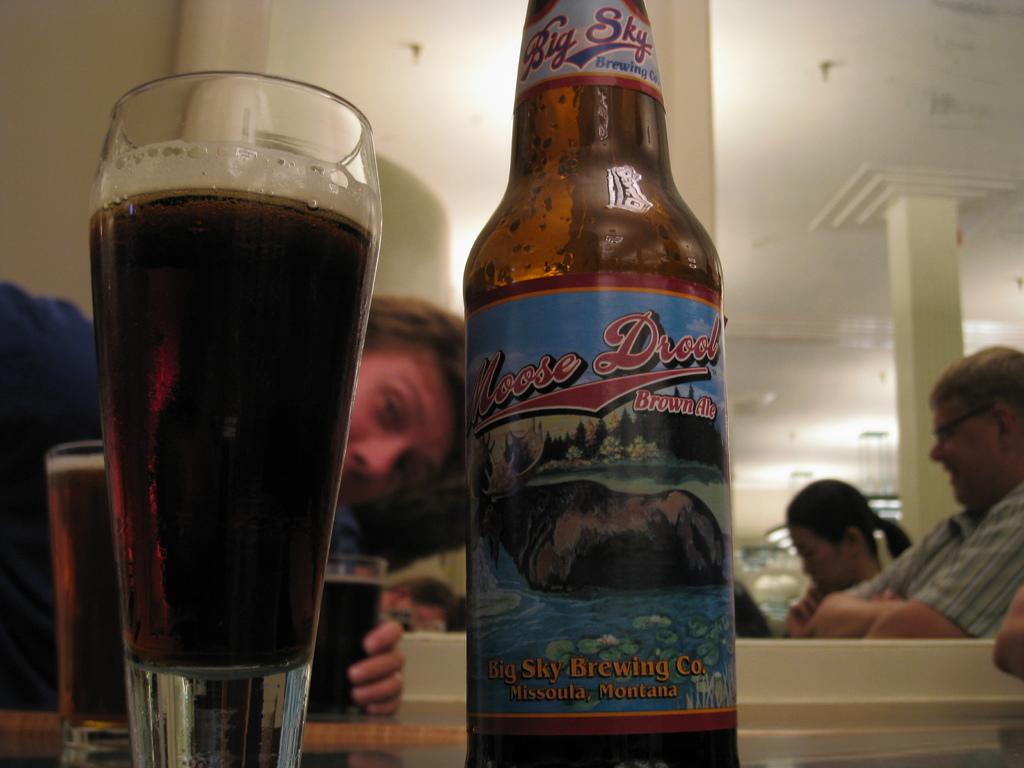How many people are in the image? There are persons in the image. What is one person holding in the image? One person is holding a glass. What else can be seen in the image besides the persons? There is a bottle in the image. What is in the glass that the person is holding? There is a drink in the glass. What type of quince is being used as a decoration in the image? There is no quince present in the image. What authority figure is depicted in the image? There is no authority figure depicted in the image. 